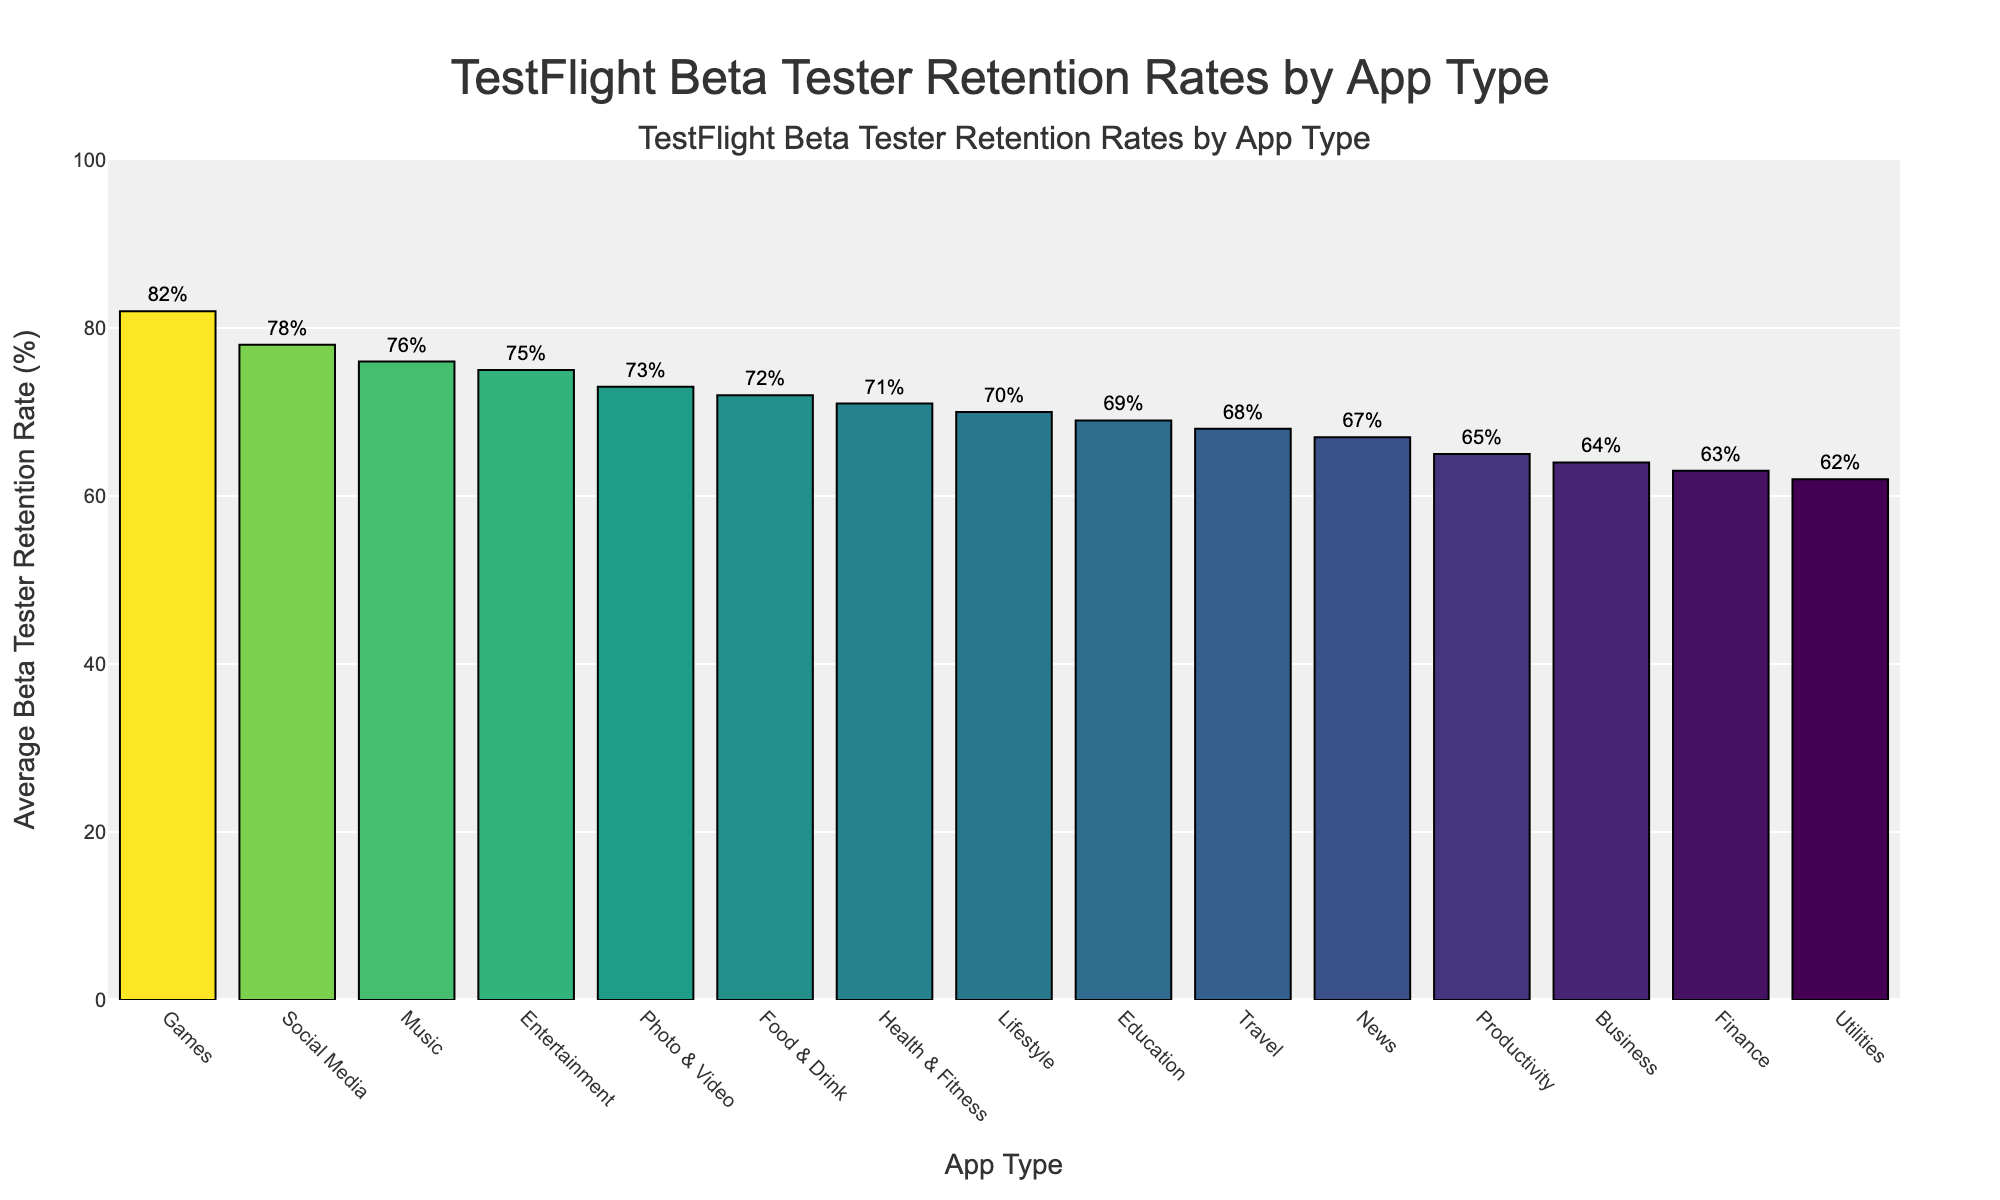Which app type has the highest average beta tester retention rate? By inspecting the figure, the "Games" app type has the highest bar, indicating the highest average retention rate of 82%.
Answer: Games Which app type has the lowest average beta tester retention rate? By looking at the figure, the "Utilities" app type has the shortest bar, indicating the lowest retention rate of 62%.
Answer: Utilities How much higher is the retention rate for Social Media apps compared to Finance apps? The retention rate for Social Media apps is 78%, while for Finance apps it is 63%. The difference is 78% - 63% = 15%.
Answer: 15% What is the average beta tester retention rate for Entertainment and Music apps combined? The retention rates for Entertainment and Music apps are 75% and 76%, respectively. The combined average is (75 + 76) / 2 = 75.5%.
Answer: 75.5% How does the retention rate for Health & Fitness apps compare to the average retention rate of all other app types? First, calculate the average retention rate of all app types excluding Health & Fitness. Sum all rates excluding Health & Fitness = 78% + 65% + 82% + 69% + 63% + 75% + 68% + 73% + 70% + 62% + 67% + 64% + 76% + 72% = 984%. There are 14 other app types, so their average is 984 / 14 = 70.29%. The retention rate for Health & Fitness is 71%, which is slightly higher than this average.
Answer: Slightly higher Which has a greater impact, the retention rate of Games or the rate of Social Media? By comparing the figure, Games have a retention rate of 82%, and Social Media has a retention rate of 78%. Thus, Games have a greater impact.
Answer: Games What is the retention rate difference between the highest and the lowest app types? The highest retention rate is for Games (82%) and the lowest is for Utilities (62%). The difference is 82% - 62% = 20%.
Answer: 20% Which app types have retention rates above 70%? By inspecting the figure, Social Media, Games, Health & Fitness, Entertainment, Photo & Video, Lifestyle, Music, and Food & Drink all have retention rates above 70%.
Answer: Social Media, Games, Health & Fitness, Entertainment, Photo & Video, Lifestyle, Music, Food & Drink What is the combined average retention rate for Education and Travel app types? The retention rates for Education and Travel are 69% and 68%, respectively. The combined average is (69 + 68) / 2 = 68.5%.
Answer: 68.5% 